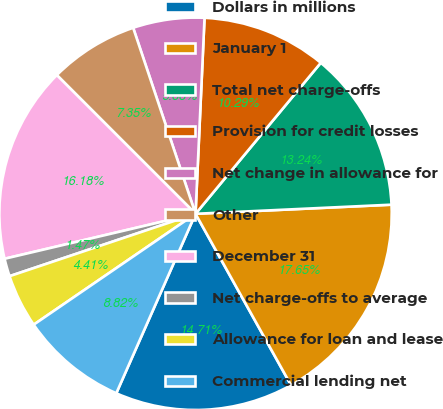Convert chart. <chart><loc_0><loc_0><loc_500><loc_500><pie_chart><fcel>Dollars in millions<fcel>January 1<fcel>Total net charge-offs<fcel>Provision for credit losses<fcel>Net change in allowance for<fcel>Other<fcel>December 31<fcel>Net charge-offs to average<fcel>Allowance for loan and lease<fcel>Commercial lending net<nl><fcel>14.71%<fcel>17.65%<fcel>13.24%<fcel>10.29%<fcel>5.88%<fcel>7.35%<fcel>16.18%<fcel>1.47%<fcel>4.41%<fcel>8.82%<nl></chart> 